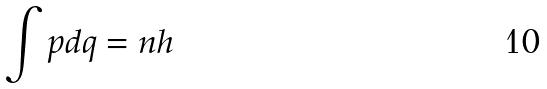<formula> <loc_0><loc_0><loc_500><loc_500>\int p d q = n h</formula> 